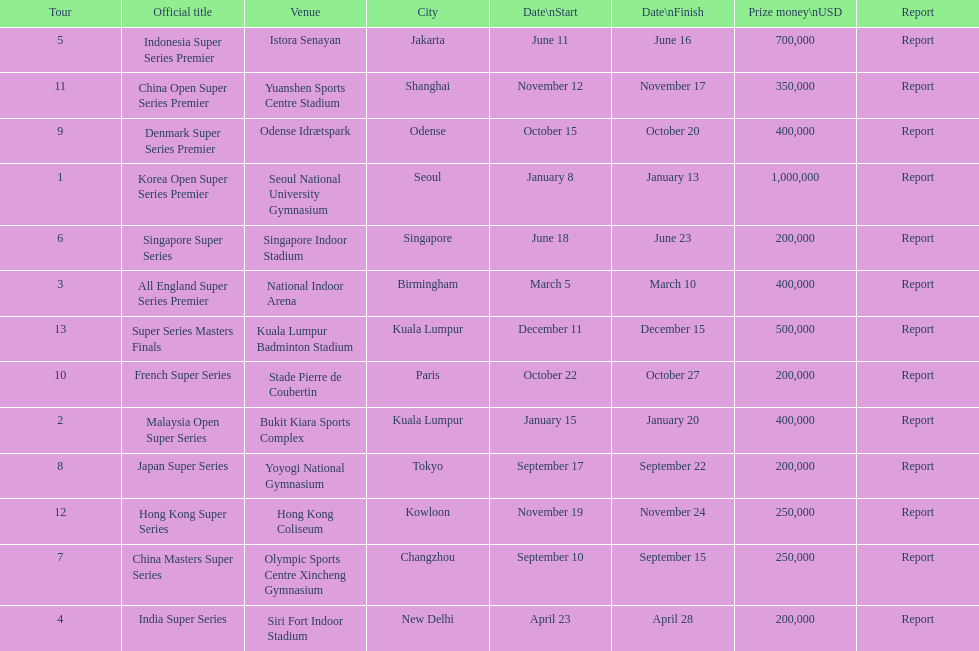How many events of the 2013 bwf super series pay over $200,000? 9. 